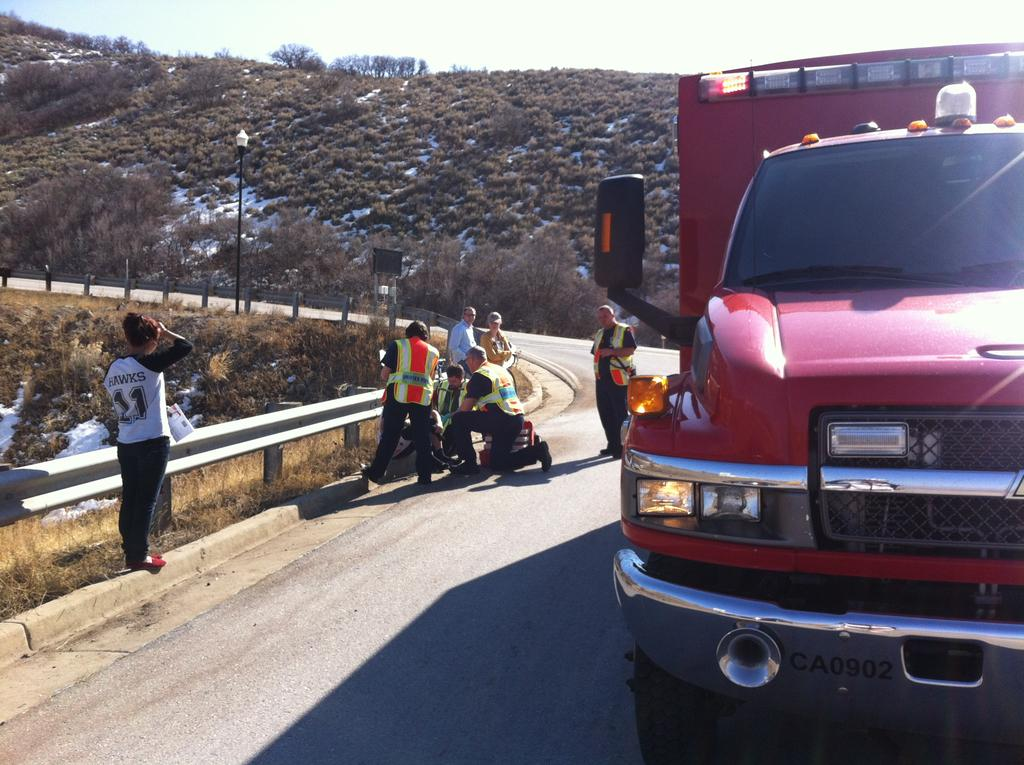What type of vehicle is on the road in the image? There is a truck on the road in the image. What are the people in the image doing? The people are standing beside a fence in the image. What object can be seen near the road in the image? There is a street pole visible in the image. What can be seen in the distance in the image? There is a hill in the background of the image, and trees are present as well. How would you describe the sky in the image? The sky is visible in the background of the image, and it appears cloudy. What type of brass instrument is being played by the people standing beside the fence in the image? There is no brass instrument being played in the image; the people are simply standing beside a fence. What type of system is responsible for the cloudy sky in the image? The cloudy sky in the image is a natural weather phenomenon and is not the result of any specific system. 